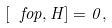Convert formula to latex. <formula><loc_0><loc_0><loc_500><loc_500>[ \ f o p , H ] = 0 ,</formula> 